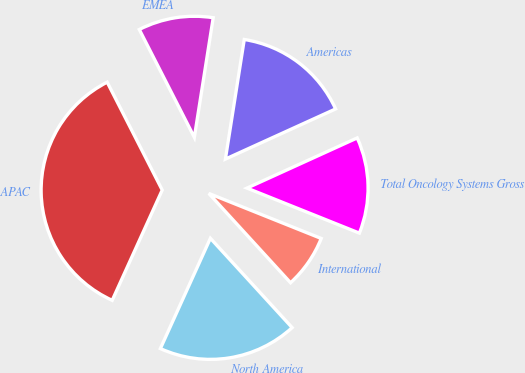Convert chart. <chart><loc_0><loc_0><loc_500><loc_500><pie_chart><fcel>Americas<fcel>EMEA<fcel>APAC<fcel>North America<fcel>International<fcel>Total Oncology Systems Gross<nl><fcel>15.71%<fcel>10.0%<fcel>35.71%<fcel>18.57%<fcel>7.14%<fcel>12.86%<nl></chart> 